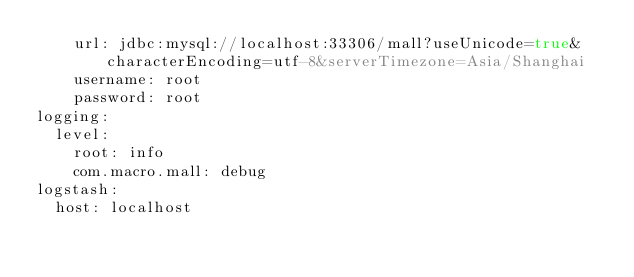<code> <loc_0><loc_0><loc_500><loc_500><_YAML_>    url: jdbc:mysql://localhost:33306/mall?useUnicode=true&characterEncoding=utf-8&serverTimezone=Asia/Shanghai
    username: root
    password: root
logging:
  level:
    root: info
    com.macro.mall: debug
logstash:
  host: localhost</code> 